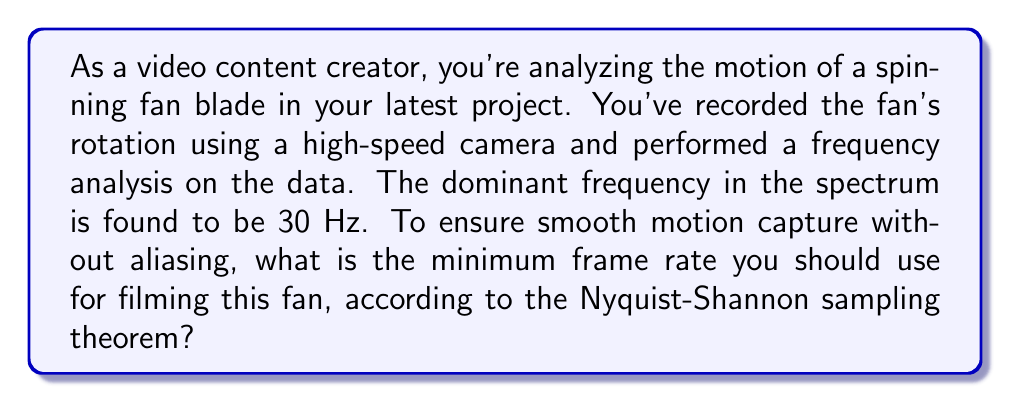Can you answer this question? To solve this problem, we need to apply the Nyquist-Shannon sampling theorem, which is fundamental in digital signal processing and directly applies to video frame rates. Let's break down the solution step-by-step:

1. Understand the Nyquist-Shannon sampling theorem:
   The theorem states that to accurately reconstruct a signal, the sampling rate must be at least twice the highest frequency component in the signal.

2. Identify the highest frequency component:
   In this case, the dominant frequency of the fan's rotation is 30 Hz.

3. Apply the theorem:
   Minimum sampling rate = 2 * highest frequency
   $$ f_s \geq 2f_{max} $$
   Where $f_s$ is the sampling rate (frame rate in this case) and $f_{max}$ is the highest frequency component.

4. Calculate the minimum frame rate:
   $$ f_s \geq 2 * 30\text{ Hz} = 60\text{ Hz} $$

5. Consider practical implications:
   In video production, standard frame rates are typically multiples of common refresh rates. The next standard frame rate above 60 Hz is 120 Hz.

As a content creator, understanding this concept allows you to make informed decisions about your equipment and settings, ensuring that you capture smooth motion without artifacts like aliasing or strobing effects.
Answer: The minimum frame rate for smooth motion capture of the fan is 60 frames per second (fps). However, for practical video production, using the next standard frame rate of 120 fps would be recommended. 